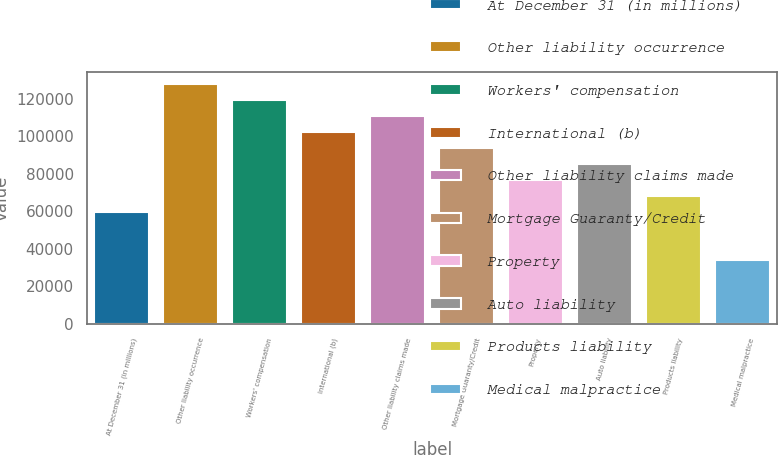<chart> <loc_0><loc_0><loc_500><loc_500><bar_chart><fcel>At December 31 (in millions)<fcel>Other liability occurrence<fcel>Workers' compensation<fcel>International (b)<fcel>Other liability claims made<fcel>Mortgage Guaranty/Credit<fcel>Property<fcel>Auto liability<fcel>Products liability<fcel>Medical malpractice<nl><fcel>59816.4<fcel>128002<fcel>119479<fcel>102432<fcel>110956<fcel>93909.2<fcel>76862.8<fcel>85386<fcel>68339.6<fcel>34246.8<nl></chart> 